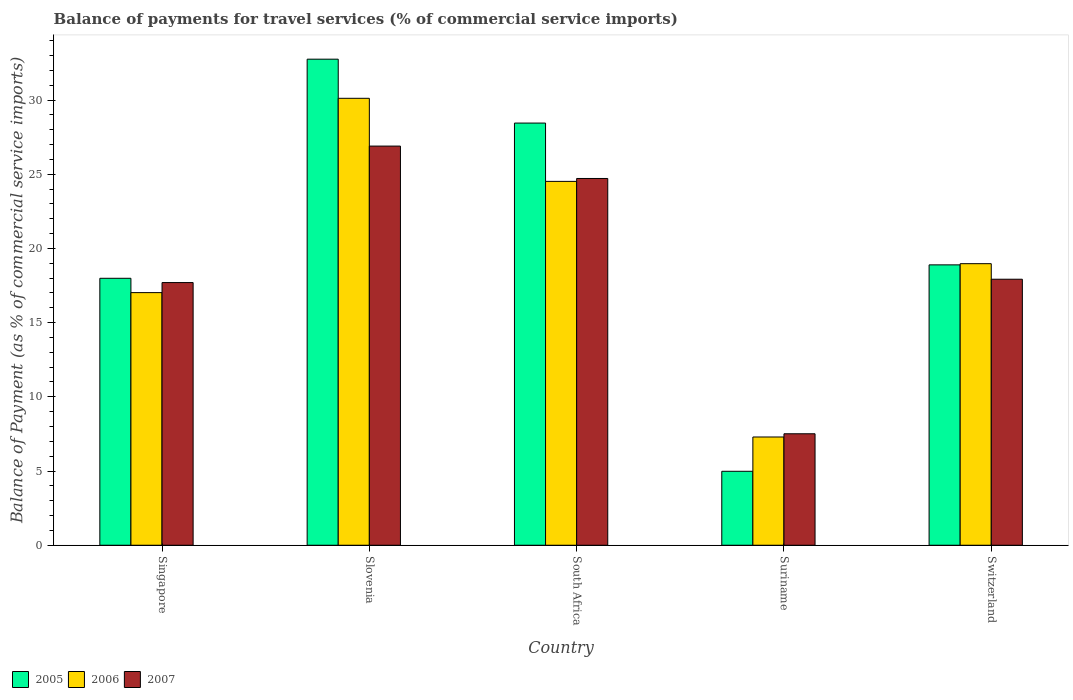How many different coloured bars are there?
Your answer should be very brief. 3. How many groups of bars are there?
Your response must be concise. 5. Are the number of bars per tick equal to the number of legend labels?
Keep it short and to the point. Yes. Are the number of bars on each tick of the X-axis equal?
Your response must be concise. Yes. What is the label of the 3rd group of bars from the left?
Your response must be concise. South Africa. What is the balance of payments for travel services in 2005 in Slovenia?
Your answer should be very brief. 32.75. Across all countries, what is the maximum balance of payments for travel services in 2007?
Offer a terse response. 26.9. Across all countries, what is the minimum balance of payments for travel services in 2007?
Your answer should be compact. 7.51. In which country was the balance of payments for travel services in 2007 maximum?
Your response must be concise. Slovenia. In which country was the balance of payments for travel services in 2007 minimum?
Provide a short and direct response. Suriname. What is the total balance of payments for travel services in 2006 in the graph?
Provide a succinct answer. 97.92. What is the difference between the balance of payments for travel services in 2006 in Suriname and that in Switzerland?
Provide a succinct answer. -11.68. What is the difference between the balance of payments for travel services in 2006 in Slovenia and the balance of payments for travel services in 2007 in Suriname?
Your response must be concise. 22.6. What is the average balance of payments for travel services in 2006 per country?
Your answer should be compact. 19.58. What is the difference between the balance of payments for travel services of/in 2006 and balance of payments for travel services of/in 2007 in South Africa?
Provide a succinct answer. -0.2. In how many countries, is the balance of payments for travel services in 2006 greater than 1 %?
Your response must be concise. 5. What is the ratio of the balance of payments for travel services in 2006 in Slovenia to that in South Africa?
Offer a terse response. 1.23. Is the balance of payments for travel services in 2007 in Singapore less than that in Suriname?
Your response must be concise. No. What is the difference between the highest and the second highest balance of payments for travel services in 2007?
Provide a short and direct response. 6.79. What is the difference between the highest and the lowest balance of payments for travel services in 2007?
Provide a short and direct response. 19.38. Is the sum of the balance of payments for travel services in 2005 in Singapore and Suriname greater than the maximum balance of payments for travel services in 2006 across all countries?
Make the answer very short. No. What does the 1st bar from the left in Singapore represents?
Your response must be concise. 2005. What does the 2nd bar from the right in South Africa represents?
Keep it short and to the point. 2006. Is it the case that in every country, the sum of the balance of payments for travel services in 2005 and balance of payments for travel services in 2006 is greater than the balance of payments for travel services in 2007?
Provide a succinct answer. Yes. How many bars are there?
Make the answer very short. 15. Are all the bars in the graph horizontal?
Your response must be concise. No. What is the difference between two consecutive major ticks on the Y-axis?
Provide a short and direct response. 5. Are the values on the major ticks of Y-axis written in scientific E-notation?
Provide a short and direct response. No. Does the graph contain any zero values?
Give a very brief answer. No. Where does the legend appear in the graph?
Offer a terse response. Bottom left. What is the title of the graph?
Provide a short and direct response. Balance of payments for travel services (% of commercial service imports). Does "1981" appear as one of the legend labels in the graph?
Your answer should be very brief. No. What is the label or title of the X-axis?
Your answer should be compact. Country. What is the label or title of the Y-axis?
Your response must be concise. Balance of Payment (as % of commercial service imports). What is the Balance of Payment (as % of commercial service imports) of 2005 in Singapore?
Your response must be concise. 17.99. What is the Balance of Payment (as % of commercial service imports) in 2006 in Singapore?
Keep it short and to the point. 17.02. What is the Balance of Payment (as % of commercial service imports) in 2007 in Singapore?
Your response must be concise. 17.7. What is the Balance of Payment (as % of commercial service imports) of 2005 in Slovenia?
Provide a short and direct response. 32.75. What is the Balance of Payment (as % of commercial service imports) of 2006 in Slovenia?
Your answer should be compact. 30.11. What is the Balance of Payment (as % of commercial service imports) of 2007 in Slovenia?
Offer a very short reply. 26.9. What is the Balance of Payment (as % of commercial service imports) of 2005 in South Africa?
Offer a terse response. 28.45. What is the Balance of Payment (as % of commercial service imports) of 2006 in South Africa?
Your response must be concise. 24.52. What is the Balance of Payment (as % of commercial service imports) of 2007 in South Africa?
Ensure brevity in your answer.  24.71. What is the Balance of Payment (as % of commercial service imports) of 2005 in Suriname?
Give a very brief answer. 4.98. What is the Balance of Payment (as % of commercial service imports) of 2006 in Suriname?
Give a very brief answer. 7.29. What is the Balance of Payment (as % of commercial service imports) in 2007 in Suriname?
Offer a terse response. 7.51. What is the Balance of Payment (as % of commercial service imports) in 2005 in Switzerland?
Your answer should be compact. 18.89. What is the Balance of Payment (as % of commercial service imports) in 2006 in Switzerland?
Your answer should be very brief. 18.97. What is the Balance of Payment (as % of commercial service imports) in 2007 in Switzerland?
Your response must be concise. 17.92. Across all countries, what is the maximum Balance of Payment (as % of commercial service imports) in 2005?
Your response must be concise. 32.75. Across all countries, what is the maximum Balance of Payment (as % of commercial service imports) in 2006?
Your response must be concise. 30.11. Across all countries, what is the maximum Balance of Payment (as % of commercial service imports) of 2007?
Your answer should be compact. 26.9. Across all countries, what is the minimum Balance of Payment (as % of commercial service imports) in 2005?
Ensure brevity in your answer.  4.98. Across all countries, what is the minimum Balance of Payment (as % of commercial service imports) in 2006?
Your answer should be very brief. 7.29. Across all countries, what is the minimum Balance of Payment (as % of commercial service imports) of 2007?
Give a very brief answer. 7.51. What is the total Balance of Payment (as % of commercial service imports) of 2005 in the graph?
Ensure brevity in your answer.  103.06. What is the total Balance of Payment (as % of commercial service imports) in 2006 in the graph?
Provide a succinct answer. 97.92. What is the total Balance of Payment (as % of commercial service imports) in 2007 in the graph?
Your answer should be very brief. 94.74. What is the difference between the Balance of Payment (as % of commercial service imports) of 2005 in Singapore and that in Slovenia?
Provide a short and direct response. -14.76. What is the difference between the Balance of Payment (as % of commercial service imports) of 2006 in Singapore and that in Slovenia?
Your answer should be very brief. -13.09. What is the difference between the Balance of Payment (as % of commercial service imports) of 2007 in Singapore and that in Slovenia?
Provide a succinct answer. -9.2. What is the difference between the Balance of Payment (as % of commercial service imports) of 2005 in Singapore and that in South Africa?
Your answer should be very brief. -10.46. What is the difference between the Balance of Payment (as % of commercial service imports) in 2006 in Singapore and that in South Africa?
Give a very brief answer. -7.5. What is the difference between the Balance of Payment (as % of commercial service imports) in 2007 in Singapore and that in South Africa?
Give a very brief answer. -7.01. What is the difference between the Balance of Payment (as % of commercial service imports) in 2005 in Singapore and that in Suriname?
Make the answer very short. 13.01. What is the difference between the Balance of Payment (as % of commercial service imports) of 2006 in Singapore and that in Suriname?
Offer a terse response. 9.73. What is the difference between the Balance of Payment (as % of commercial service imports) in 2007 in Singapore and that in Suriname?
Your answer should be compact. 10.19. What is the difference between the Balance of Payment (as % of commercial service imports) of 2005 in Singapore and that in Switzerland?
Make the answer very short. -0.9. What is the difference between the Balance of Payment (as % of commercial service imports) of 2006 in Singapore and that in Switzerland?
Provide a succinct answer. -1.95. What is the difference between the Balance of Payment (as % of commercial service imports) of 2007 in Singapore and that in Switzerland?
Ensure brevity in your answer.  -0.23. What is the difference between the Balance of Payment (as % of commercial service imports) of 2005 in Slovenia and that in South Africa?
Provide a succinct answer. 4.3. What is the difference between the Balance of Payment (as % of commercial service imports) of 2006 in Slovenia and that in South Africa?
Give a very brief answer. 5.6. What is the difference between the Balance of Payment (as % of commercial service imports) in 2007 in Slovenia and that in South Africa?
Your response must be concise. 2.18. What is the difference between the Balance of Payment (as % of commercial service imports) of 2005 in Slovenia and that in Suriname?
Your answer should be very brief. 27.77. What is the difference between the Balance of Payment (as % of commercial service imports) of 2006 in Slovenia and that in Suriname?
Make the answer very short. 22.82. What is the difference between the Balance of Payment (as % of commercial service imports) of 2007 in Slovenia and that in Suriname?
Provide a short and direct response. 19.38. What is the difference between the Balance of Payment (as % of commercial service imports) of 2005 in Slovenia and that in Switzerland?
Ensure brevity in your answer.  13.86. What is the difference between the Balance of Payment (as % of commercial service imports) of 2006 in Slovenia and that in Switzerland?
Your response must be concise. 11.14. What is the difference between the Balance of Payment (as % of commercial service imports) in 2007 in Slovenia and that in Switzerland?
Provide a succinct answer. 8.97. What is the difference between the Balance of Payment (as % of commercial service imports) in 2005 in South Africa and that in Suriname?
Offer a terse response. 23.46. What is the difference between the Balance of Payment (as % of commercial service imports) of 2006 in South Africa and that in Suriname?
Provide a short and direct response. 17.22. What is the difference between the Balance of Payment (as % of commercial service imports) in 2007 in South Africa and that in Suriname?
Give a very brief answer. 17.2. What is the difference between the Balance of Payment (as % of commercial service imports) of 2005 in South Africa and that in Switzerland?
Provide a succinct answer. 9.56. What is the difference between the Balance of Payment (as % of commercial service imports) in 2006 in South Africa and that in Switzerland?
Your answer should be very brief. 5.55. What is the difference between the Balance of Payment (as % of commercial service imports) in 2007 in South Africa and that in Switzerland?
Your response must be concise. 6.79. What is the difference between the Balance of Payment (as % of commercial service imports) in 2005 in Suriname and that in Switzerland?
Your answer should be compact. -13.91. What is the difference between the Balance of Payment (as % of commercial service imports) of 2006 in Suriname and that in Switzerland?
Offer a terse response. -11.68. What is the difference between the Balance of Payment (as % of commercial service imports) in 2007 in Suriname and that in Switzerland?
Offer a terse response. -10.41. What is the difference between the Balance of Payment (as % of commercial service imports) of 2005 in Singapore and the Balance of Payment (as % of commercial service imports) of 2006 in Slovenia?
Make the answer very short. -12.13. What is the difference between the Balance of Payment (as % of commercial service imports) in 2005 in Singapore and the Balance of Payment (as % of commercial service imports) in 2007 in Slovenia?
Keep it short and to the point. -8.91. What is the difference between the Balance of Payment (as % of commercial service imports) of 2006 in Singapore and the Balance of Payment (as % of commercial service imports) of 2007 in Slovenia?
Make the answer very short. -9.87. What is the difference between the Balance of Payment (as % of commercial service imports) in 2005 in Singapore and the Balance of Payment (as % of commercial service imports) in 2006 in South Africa?
Make the answer very short. -6.53. What is the difference between the Balance of Payment (as % of commercial service imports) in 2005 in Singapore and the Balance of Payment (as % of commercial service imports) in 2007 in South Africa?
Your response must be concise. -6.73. What is the difference between the Balance of Payment (as % of commercial service imports) of 2006 in Singapore and the Balance of Payment (as % of commercial service imports) of 2007 in South Africa?
Offer a terse response. -7.69. What is the difference between the Balance of Payment (as % of commercial service imports) of 2005 in Singapore and the Balance of Payment (as % of commercial service imports) of 2006 in Suriname?
Ensure brevity in your answer.  10.69. What is the difference between the Balance of Payment (as % of commercial service imports) of 2005 in Singapore and the Balance of Payment (as % of commercial service imports) of 2007 in Suriname?
Offer a very short reply. 10.48. What is the difference between the Balance of Payment (as % of commercial service imports) in 2006 in Singapore and the Balance of Payment (as % of commercial service imports) in 2007 in Suriname?
Make the answer very short. 9.51. What is the difference between the Balance of Payment (as % of commercial service imports) in 2005 in Singapore and the Balance of Payment (as % of commercial service imports) in 2006 in Switzerland?
Ensure brevity in your answer.  -0.98. What is the difference between the Balance of Payment (as % of commercial service imports) in 2005 in Singapore and the Balance of Payment (as % of commercial service imports) in 2007 in Switzerland?
Ensure brevity in your answer.  0.06. What is the difference between the Balance of Payment (as % of commercial service imports) in 2006 in Singapore and the Balance of Payment (as % of commercial service imports) in 2007 in Switzerland?
Provide a short and direct response. -0.9. What is the difference between the Balance of Payment (as % of commercial service imports) in 2005 in Slovenia and the Balance of Payment (as % of commercial service imports) in 2006 in South Africa?
Your answer should be compact. 8.23. What is the difference between the Balance of Payment (as % of commercial service imports) of 2005 in Slovenia and the Balance of Payment (as % of commercial service imports) of 2007 in South Africa?
Your answer should be very brief. 8.04. What is the difference between the Balance of Payment (as % of commercial service imports) in 2006 in Slovenia and the Balance of Payment (as % of commercial service imports) in 2007 in South Africa?
Ensure brevity in your answer.  5.4. What is the difference between the Balance of Payment (as % of commercial service imports) of 2005 in Slovenia and the Balance of Payment (as % of commercial service imports) of 2006 in Suriname?
Keep it short and to the point. 25.46. What is the difference between the Balance of Payment (as % of commercial service imports) in 2005 in Slovenia and the Balance of Payment (as % of commercial service imports) in 2007 in Suriname?
Your answer should be compact. 25.24. What is the difference between the Balance of Payment (as % of commercial service imports) in 2006 in Slovenia and the Balance of Payment (as % of commercial service imports) in 2007 in Suriname?
Make the answer very short. 22.6. What is the difference between the Balance of Payment (as % of commercial service imports) in 2005 in Slovenia and the Balance of Payment (as % of commercial service imports) in 2006 in Switzerland?
Offer a terse response. 13.78. What is the difference between the Balance of Payment (as % of commercial service imports) in 2005 in Slovenia and the Balance of Payment (as % of commercial service imports) in 2007 in Switzerland?
Your answer should be compact. 14.83. What is the difference between the Balance of Payment (as % of commercial service imports) of 2006 in Slovenia and the Balance of Payment (as % of commercial service imports) of 2007 in Switzerland?
Provide a succinct answer. 12.19. What is the difference between the Balance of Payment (as % of commercial service imports) in 2005 in South Africa and the Balance of Payment (as % of commercial service imports) in 2006 in Suriname?
Provide a short and direct response. 21.15. What is the difference between the Balance of Payment (as % of commercial service imports) of 2005 in South Africa and the Balance of Payment (as % of commercial service imports) of 2007 in Suriname?
Offer a very short reply. 20.94. What is the difference between the Balance of Payment (as % of commercial service imports) in 2006 in South Africa and the Balance of Payment (as % of commercial service imports) in 2007 in Suriname?
Your answer should be very brief. 17.01. What is the difference between the Balance of Payment (as % of commercial service imports) of 2005 in South Africa and the Balance of Payment (as % of commercial service imports) of 2006 in Switzerland?
Offer a terse response. 9.48. What is the difference between the Balance of Payment (as % of commercial service imports) in 2005 in South Africa and the Balance of Payment (as % of commercial service imports) in 2007 in Switzerland?
Provide a short and direct response. 10.52. What is the difference between the Balance of Payment (as % of commercial service imports) of 2006 in South Africa and the Balance of Payment (as % of commercial service imports) of 2007 in Switzerland?
Keep it short and to the point. 6.59. What is the difference between the Balance of Payment (as % of commercial service imports) of 2005 in Suriname and the Balance of Payment (as % of commercial service imports) of 2006 in Switzerland?
Ensure brevity in your answer.  -13.99. What is the difference between the Balance of Payment (as % of commercial service imports) in 2005 in Suriname and the Balance of Payment (as % of commercial service imports) in 2007 in Switzerland?
Ensure brevity in your answer.  -12.94. What is the difference between the Balance of Payment (as % of commercial service imports) in 2006 in Suriname and the Balance of Payment (as % of commercial service imports) in 2007 in Switzerland?
Provide a short and direct response. -10.63. What is the average Balance of Payment (as % of commercial service imports) in 2005 per country?
Offer a terse response. 20.61. What is the average Balance of Payment (as % of commercial service imports) of 2006 per country?
Provide a short and direct response. 19.58. What is the average Balance of Payment (as % of commercial service imports) in 2007 per country?
Offer a very short reply. 18.95. What is the difference between the Balance of Payment (as % of commercial service imports) in 2005 and Balance of Payment (as % of commercial service imports) in 2006 in Singapore?
Give a very brief answer. 0.97. What is the difference between the Balance of Payment (as % of commercial service imports) in 2005 and Balance of Payment (as % of commercial service imports) in 2007 in Singapore?
Ensure brevity in your answer.  0.29. What is the difference between the Balance of Payment (as % of commercial service imports) of 2006 and Balance of Payment (as % of commercial service imports) of 2007 in Singapore?
Provide a short and direct response. -0.68. What is the difference between the Balance of Payment (as % of commercial service imports) of 2005 and Balance of Payment (as % of commercial service imports) of 2006 in Slovenia?
Provide a short and direct response. 2.64. What is the difference between the Balance of Payment (as % of commercial service imports) of 2005 and Balance of Payment (as % of commercial service imports) of 2007 in Slovenia?
Provide a succinct answer. 5.86. What is the difference between the Balance of Payment (as % of commercial service imports) in 2006 and Balance of Payment (as % of commercial service imports) in 2007 in Slovenia?
Your answer should be very brief. 3.22. What is the difference between the Balance of Payment (as % of commercial service imports) in 2005 and Balance of Payment (as % of commercial service imports) in 2006 in South Africa?
Your answer should be very brief. 3.93. What is the difference between the Balance of Payment (as % of commercial service imports) in 2005 and Balance of Payment (as % of commercial service imports) in 2007 in South Africa?
Keep it short and to the point. 3.73. What is the difference between the Balance of Payment (as % of commercial service imports) in 2006 and Balance of Payment (as % of commercial service imports) in 2007 in South Africa?
Your answer should be compact. -0.2. What is the difference between the Balance of Payment (as % of commercial service imports) in 2005 and Balance of Payment (as % of commercial service imports) in 2006 in Suriname?
Provide a succinct answer. -2.31. What is the difference between the Balance of Payment (as % of commercial service imports) of 2005 and Balance of Payment (as % of commercial service imports) of 2007 in Suriname?
Provide a succinct answer. -2.53. What is the difference between the Balance of Payment (as % of commercial service imports) of 2006 and Balance of Payment (as % of commercial service imports) of 2007 in Suriname?
Keep it short and to the point. -0.22. What is the difference between the Balance of Payment (as % of commercial service imports) of 2005 and Balance of Payment (as % of commercial service imports) of 2006 in Switzerland?
Keep it short and to the point. -0.08. What is the difference between the Balance of Payment (as % of commercial service imports) of 2005 and Balance of Payment (as % of commercial service imports) of 2007 in Switzerland?
Offer a terse response. 0.97. What is the difference between the Balance of Payment (as % of commercial service imports) in 2006 and Balance of Payment (as % of commercial service imports) in 2007 in Switzerland?
Provide a short and direct response. 1.05. What is the ratio of the Balance of Payment (as % of commercial service imports) in 2005 in Singapore to that in Slovenia?
Make the answer very short. 0.55. What is the ratio of the Balance of Payment (as % of commercial service imports) in 2006 in Singapore to that in Slovenia?
Your answer should be compact. 0.57. What is the ratio of the Balance of Payment (as % of commercial service imports) of 2007 in Singapore to that in Slovenia?
Keep it short and to the point. 0.66. What is the ratio of the Balance of Payment (as % of commercial service imports) in 2005 in Singapore to that in South Africa?
Your answer should be very brief. 0.63. What is the ratio of the Balance of Payment (as % of commercial service imports) in 2006 in Singapore to that in South Africa?
Keep it short and to the point. 0.69. What is the ratio of the Balance of Payment (as % of commercial service imports) in 2007 in Singapore to that in South Africa?
Your answer should be compact. 0.72. What is the ratio of the Balance of Payment (as % of commercial service imports) of 2005 in Singapore to that in Suriname?
Your answer should be compact. 3.61. What is the ratio of the Balance of Payment (as % of commercial service imports) in 2006 in Singapore to that in Suriname?
Give a very brief answer. 2.33. What is the ratio of the Balance of Payment (as % of commercial service imports) in 2007 in Singapore to that in Suriname?
Give a very brief answer. 2.36. What is the ratio of the Balance of Payment (as % of commercial service imports) of 2005 in Singapore to that in Switzerland?
Ensure brevity in your answer.  0.95. What is the ratio of the Balance of Payment (as % of commercial service imports) of 2006 in Singapore to that in Switzerland?
Ensure brevity in your answer.  0.9. What is the ratio of the Balance of Payment (as % of commercial service imports) of 2007 in Singapore to that in Switzerland?
Offer a terse response. 0.99. What is the ratio of the Balance of Payment (as % of commercial service imports) in 2005 in Slovenia to that in South Africa?
Offer a very short reply. 1.15. What is the ratio of the Balance of Payment (as % of commercial service imports) of 2006 in Slovenia to that in South Africa?
Your response must be concise. 1.23. What is the ratio of the Balance of Payment (as % of commercial service imports) in 2007 in Slovenia to that in South Africa?
Your response must be concise. 1.09. What is the ratio of the Balance of Payment (as % of commercial service imports) of 2005 in Slovenia to that in Suriname?
Offer a terse response. 6.57. What is the ratio of the Balance of Payment (as % of commercial service imports) in 2006 in Slovenia to that in Suriname?
Provide a short and direct response. 4.13. What is the ratio of the Balance of Payment (as % of commercial service imports) of 2007 in Slovenia to that in Suriname?
Provide a short and direct response. 3.58. What is the ratio of the Balance of Payment (as % of commercial service imports) of 2005 in Slovenia to that in Switzerland?
Provide a succinct answer. 1.73. What is the ratio of the Balance of Payment (as % of commercial service imports) of 2006 in Slovenia to that in Switzerland?
Offer a terse response. 1.59. What is the ratio of the Balance of Payment (as % of commercial service imports) of 2007 in Slovenia to that in Switzerland?
Provide a succinct answer. 1.5. What is the ratio of the Balance of Payment (as % of commercial service imports) in 2005 in South Africa to that in Suriname?
Your answer should be compact. 5.71. What is the ratio of the Balance of Payment (as % of commercial service imports) in 2006 in South Africa to that in Suriname?
Offer a very short reply. 3.36. What is the ratio of the Balance of Payment (as % of commercial service imports) of 2007 in South Africa to that in Suriname?
Your answer should be very brief. 3.29. What is the ratio of the Balance of Payment (as % of commercial service imports) of 2005 in South Africa to that in Switzerland?
Offer a terse response. 1.51. What is the ratio of the Balance of Payment (as % of commercial service imports) of 2006 in South Africa to that in Switzerland?
Give a very brief answer. 1.29. What is the ratio of the Balance of Payment (as % of commercial service imports) in 2007 in South Africa to that in Switzerland?
Your answer should be very brief. 1.38. What is the ratio of the Balance of Payment (as % of commercial service imports) in 2005 in Suriname to that in Switzerland?
Offer a terse response. 0.26. What is the ratio of the Balance of Payment (as % of commercial service imports) in 2006 in Suriname to that in Switzerland?
Provide a short and direct response. 0.38. What is the ratio of the Balance of Payment (as % of commercial service imports) in 2007 in Suriname to that in Switzerland?
Provide a short and direct response. 0.42. What is the difference between the highest and the second highest Balance of Payment (as % of commercial service imports) in 2005?
Provide a succinct answer. 4.3. What is the difference between the highest and the second highest Balance of Payment (as % of commercial service imports) of 2006?
Keep it short and to the point. 5.6. What is the difference between the highest and the second highest Balance of Payment (as % of commercial service imports) of 2007?
Offer a terse response. 2.18. What is the difference between the highest and the lowest Balance of Payment (as % of commercial service imports) in 2005?
Give a very brief answer. 27.77. What is the difference between the highest and the lowest Balance of Payment (as % of commercial service imports) in 2006?
Your answer should be compact. 22.82. What is the difference between the highest and the lowest Balance of Payment (as % of commercial service imports) of 2007?
Provide a succinct answer. 19.38. 